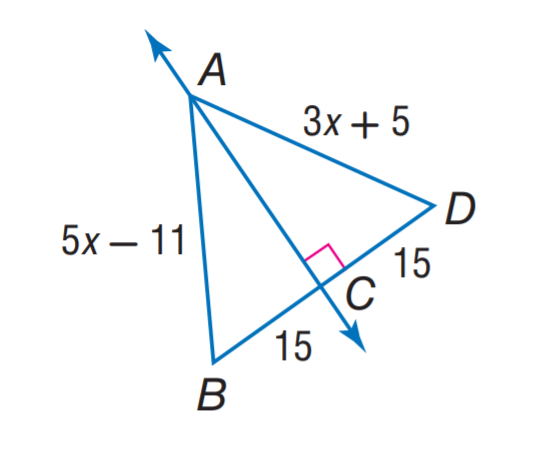Answer the mathemtical geometry problem and directly provide the correct option letter.
Question: Find A B.
Choices: A: 11 B: 15 C: 26 D: 29 D 